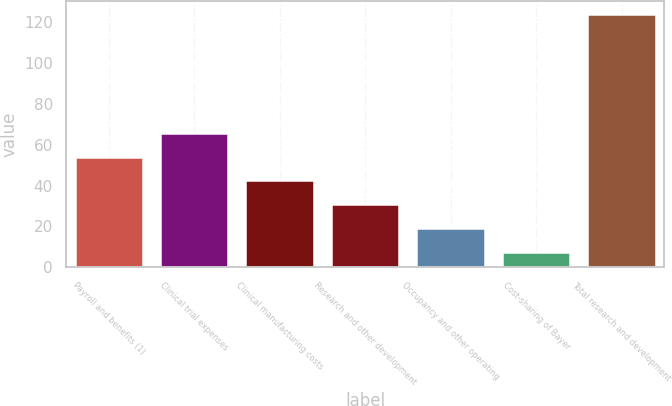Convert chart. <chart><loc_0><loc_0><loc_500><loc_500><bar_chart><fcel>Payroll and benefits (1)<fcel>Clinical trial expenses<fcel>Clinical manufacturing costs<fcel>Research and other development<fcel>Occupancy and other operating<fcel>Cost-sharing of Bayer<fcel>Total research and development<nl><fcel>54.18<fcel>65.8<fcel>42.56<fcel>30.94<fcel>19.32<fcel>7.7<fcel>123.9<nl></chart> 